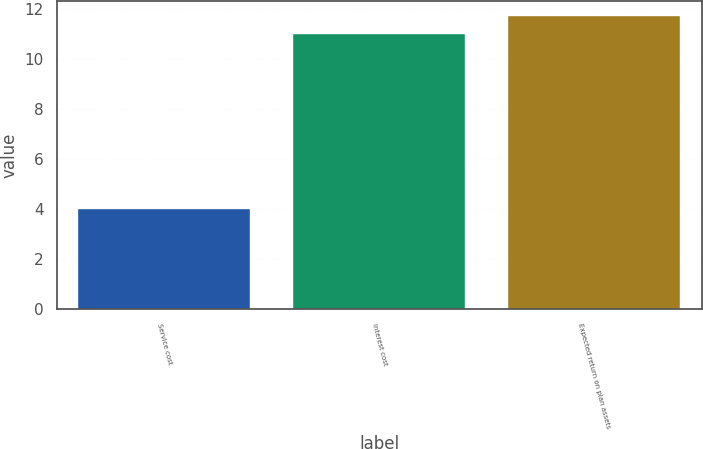Convert chart. <chart><loc_0><loc_0><loc_500><loc_500><bar_chart><fcel>Service cost<fcel>Interest cost<fcel>Expected return on plan assets<nl><fcel>4<fcel>11<fcel>11.7<nl></chart> 